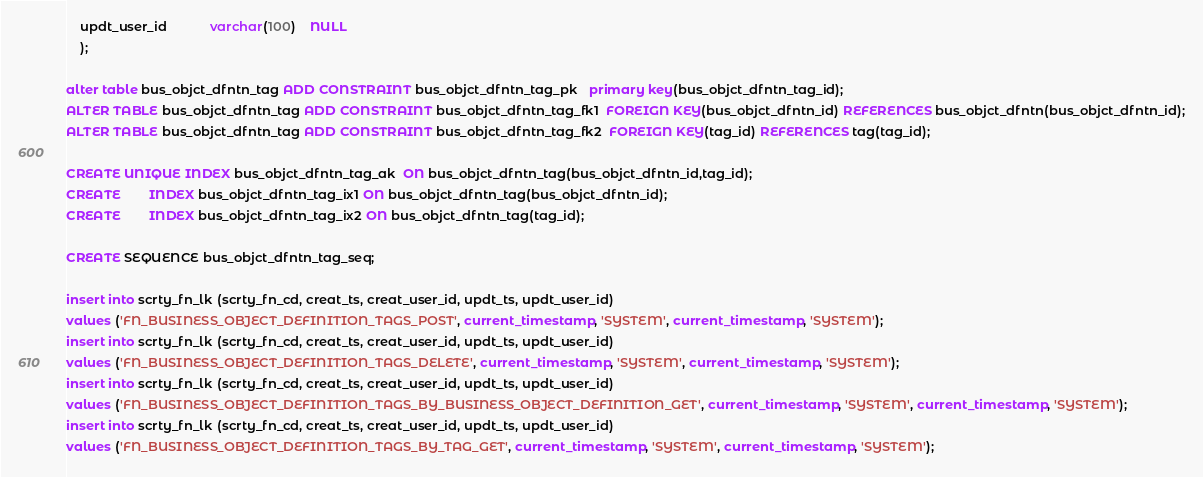<code> <loc_0><loc_0><loc_500><loc_500><_SQL_>    updt_user_id            varchar(100) 	NULL
    );
    
alter table bus_objct_dfntn_tag ADD CONSTRAINT bus_objct_dfntn_tag_pk   primary key(bus_objct_dfntn_tag_id);
ALTER TABLE bus_objct_dfntn_tag ADD CONSTRAINT bus_objct_dfntn_tag_fk1  FOREIGN KEY(bus_objct_dfntn_id) REFERENCES bus_objct_dfntn(bus_objct_dfntn_id);
ALTER TABLE bus_objct_dfntn_tag ADD CONSTRAINT bus_objct_dfntn_tag_fk2  FOREIGN KEY(tag_id) REFERENCES tag(tag_id);

CREATE UNIQUE INDEX bus_objct_dfntn_tag_ak  ON bus_objct_dfntn_tag(bus_objct_dfntn_id,tag_id);
CREATE        INDEX bus_objct_dfntn_tag_ix1 ON bus_objct_dfntn_tag(bus_objct_dfntn_id);
CREATE        INDEX bus_objct_dfntn_tag_ix2 ON bus_objct_dfntn_tag(tag_id);

CREATE SEQUENCE bus_objct_dfntn_tag_seq;

insert into scrty_fn_lk (scrty_fn_cd, creat_ts, creat_user_id, updt_ts, updt_user_id)
values ('FN_BUSINESS_OBJECT_DEFINITION_TAGS_POST', current_timestamp, 'SYSTEM', current_timestamp, 'SYSTEM');
insert into scrty_fn_lk (scrty_fn_cd, creat_ts, creat_user_id, updt_ts, updt_user_id)
values ('FN_BUSINESS_OBJECT_DEFINITION_TAGS_DELETE', current_timestamp, 'SYSTEM', current_timestamp, 'SYSTEM');
insert into scrty_fn_lk (scrty_fn_cd, creat_ts, creat_user_id, updt_ts, updt_user_id)
values ('FN_BUSINESS_OBJECT_DEFINITION_TAGS_BY_BUSINESS_OBJECT_DEFINITION_GET', current_timestamp, 'SYSTEM', current_timestamp, 'SYSTEM');
insert into scrty_fn_lk (scrty_fn_cd, creat_ts, creat_user_id, updt_ts, updt_user_id)
values ('FN_BUSINESS_OBJECT_DEFINITION_TAGS_BY_TAG_GET', current_timestamp, 'SYSTEM', current_timestamp, 'SYSTEM');


</code> 